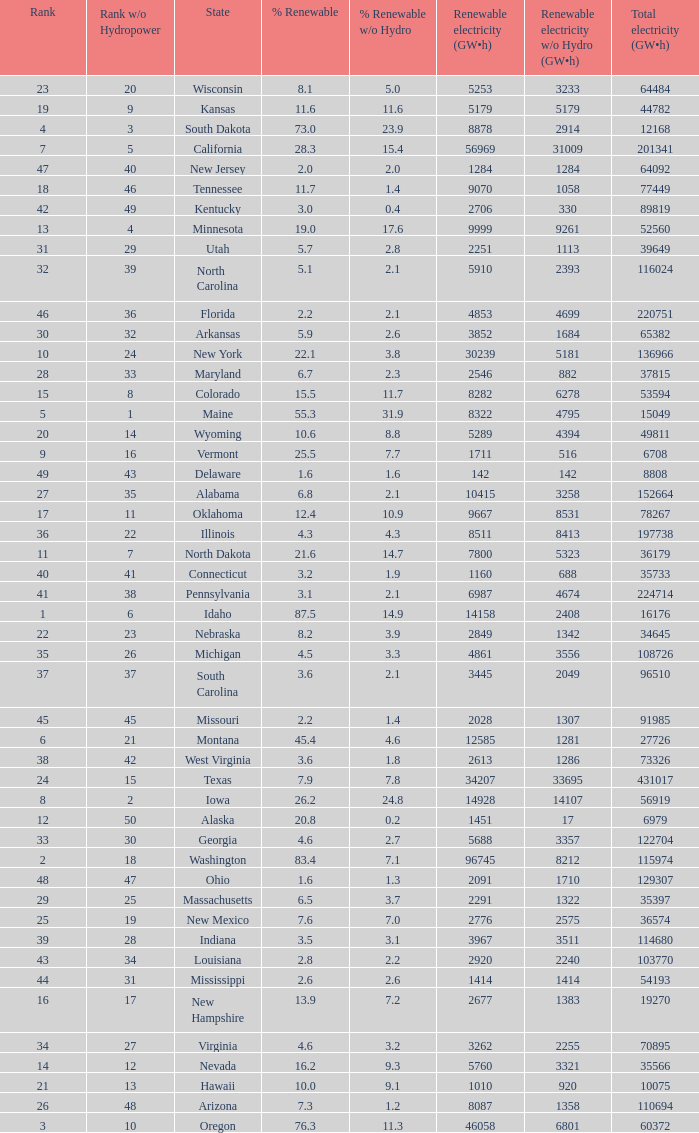What is the amount of renewable electricity without hydrogen power when the percentage of renewable energy is 83.4? 8212.0. 